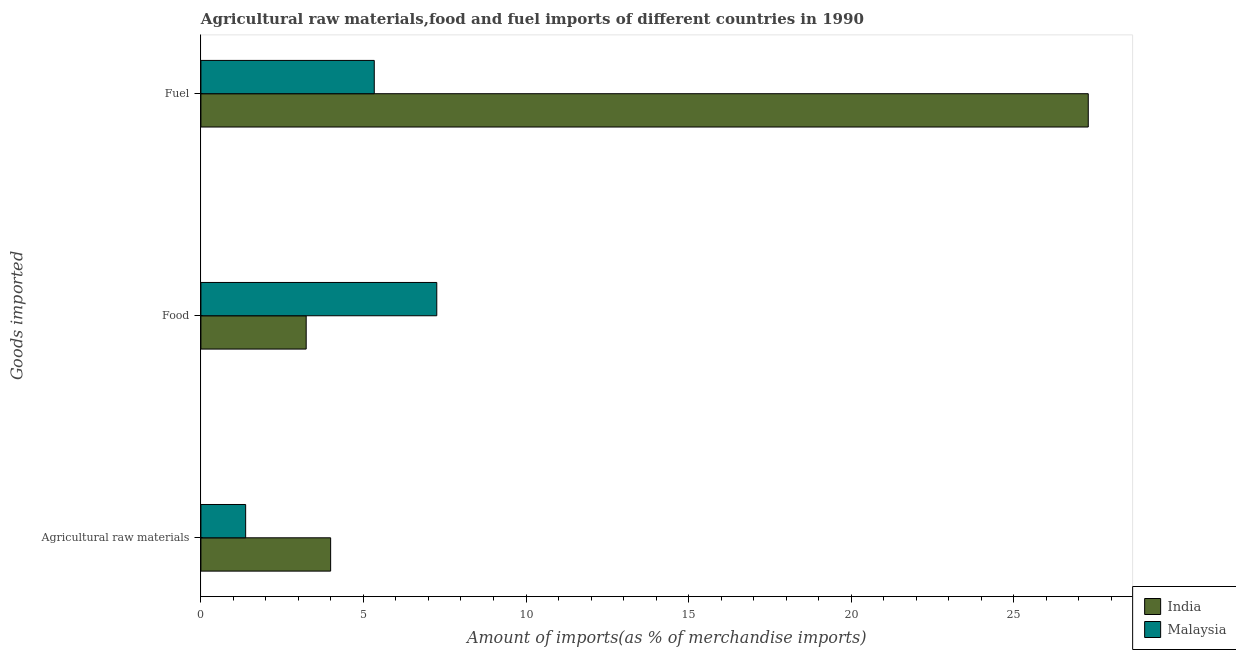How many different coloured bars are there?
Offer a terse response. 2. How many groups of bars are there?
Offer a terse response. 3. Are the number of bars on each tick of the Y-axis equal?
Ensure brevity in your answer.  Yes. How many bars are there on the 1st tick from the top?
Make the answer very short. 2. What is the label of the 2nd group of bars from the top?
Offer a very short reply. Food. What is the percentage of raw materials imports in Malaysia?
Make the answer very short. 1.38. Across all countries, what is the maximum percentage of raw materials imports?
Ensure brevity in your answer.  3.99. Across all countries, what is the minimum percentage of fuel imports?
Your response must be concise. 5.33. In which country was the percentage of raw materials imports maximum?
Give a very brief answer. India. In which country was the percentage of raw materials imports minimum?
Make the answer very short. Malaysia. What is the total percentage of fuel imports in the graph?
Your answer should be compact. 32.63. What is the difference between the percentage of food imports in India and that in Malaysia?
Offer a terse response. -4.02. What is the difference between the percentage of fuel imports in Malaysia and the percentage of raw materials imports in India?
Offer a very short reply. 1.34. What is the average percentage of food imports per country?
Your response must be concise. 5.25. What is the difference between the percentage of raw materials imports and percentage of food imports in India?
Offer a very short reply. 0.75. What is the ratio of the percentage of food imports in India to that in Malaysia?
Offer a terse response. 0.45. Is the difference between the percentage of fuel imports in Malaysia and India greater than the difference between the percentage of raw materials imports in Malaysia and India?
Provide a short and direct response. No. What is the difference between the highest and the second highest percentage of food imports?
Offer a very short reply. 4.02. What is the difference between the highest and the lowest percentage of fuel imports?
Your response must be concise. 21.96. Is the sum of the percentage of food imports in India and Malaysia greater than the maximum percentage of raw materials imports across all countries?
Make the answer very short. Yes. Is it the case that in every country, the sum of the percentage of raw materials imports and percentage of food imports is greater than the percentage of fuel imports?
Give a very brief answer. No. How many countries are there in the graph?
Keep it short and to the point. 2. Does the graph contain grids?
Your response must be concise. No. How many legend labels are there?
Offer a very short reply. 2. What is the title of the graph?
Ensure brevity in your answer.  Agricultural raw materials,food and fuel imports of different countries in 1990. Does "Montenegro" appear as one of the legend labels in the graph?
Provide a short and direct response. No. What is the label or title of the X-axis?
Your answer should be very brief. Amount of imports(as % of merchandise imports). What is the label or title of the Y-axis?
Make the answer very short. Goods imported. What is the Amount of imports(as % of merchandise imports) of India in Agricultural raw materials?
Keep it short and to the point. 3.99. What is the Amount of imports(as % of merchandise imports) in Malaysia in Agricultural raw materials?
Keep it short and to the point. 1.38. What is the Amount of imports(as % of merchandise imports) in India in Food?
Offer a very short reply. 3.24. What is the Amount of imports(as % of merchandise imports) in Malaysia in Food?
Offer a terse response. 7.26. What is the Amount of imports(as % of merchandise imports) in India in Fuel?
Your answer should be very brief. 27.3. What is the Amount of imports(as % of merchandise imports) of Malaysia in Fuel?
Give a very brief answer. 5.33. Across all Goods imported, what is the maximum Amount of imports(as % of merchandise imports) in India?
Ensure brevity in your answer.  27.3. Across all Goods imported, what is the maximum Amount of imports(as % of merchandise imports) in Malaysia?
Provide a succinct answer. 7.26. Across all Goods imported, what is the minimum Amount of imports(as % of merchandise imports) in India?
Make the answer very short. 3.24. Across all Goods imported, what is the minimum Amount of imports(as % of merchandise imports) in Malaysia?
Keep it short and to the point. 1.38. What is the total Amount of imports(as % of merchandise imports) of India in the graph?
Provide a short and direct response. 34.52. What is the total Amount of imports(as % of merchandise imports) in Malaysia in the graph?
Provide a short and direct response. 13.96. What is the difference between the Amount of imports(as % of merchandise imports) of India in Agricultural raw materials and that in Food?
Ensure brevity in your answer.  0.75. What is the difference between the Amount of imports(as % of merchandise imports) of Malaysia in Agricultural raw materials and that in Food?
Your response must be concise. -5.88. What is the difference between the Amount of imports(as % of merchandise imports) in India in Agricultural raw materials and that in Fuel?
Your answer should be very brief. -23.3. What is the difference between the Amount of imports(as % of merchandise imports) of Malaysia in Agricultural raw materials and that in Fuel?
Keep it short and to the point. -3.96. What is the difference between the Amount of imports(as % of merchandise imports) in India in Food and that in Fuel?
Offer a terse response. -24.06. What is the difference between the Amount of imports(as % of merchandise imports) in Malaysia in Food and that in Fuel?
Keep it short and to the point. 1.92. What is the difference between the Amount of imports(as % of merchandise imports) in India in Agricultural raw materials and the Amount of imports(as % of merchandise imports) in Malaysia in Food?
Offer a terse response. -3.26. What is the difference between the Amount of imports(as % of merchandise imports) of India in Agricultural raw materials and the Amount of imports(as % of merchandise imports) of Malaysia in Fuel?
Give a very brief answer. -1.34. What is the difference between the Amount of imports(as % of merchandise imports) of India in Food and the Amount of imports(as % of merchandise imports) of Malaysia in Fuel?
Make the answer very short. -2.09. What is the average Amount of imports(as % of merchandise imports) in India per Goods imported?
Provide a succinct answer. 11.51. What is the average Amount of imports(as % of merchandise imports) of Malaysia per Goods imported?
Your answer should be very brief. 4.65. What is the difference between the Amount of imports(as % of merchandise imports) in India and Amount of imports(as % of merchandise imports) in Malaysia in Agricultural raw materials?
Provide a succinct answer. 2.61. What is the difference between the Amount of imports(as % of merchandise imports) of India and Amount of imports(as % of merchandise imports) of Malaysia in Food?
Your response must be concise. -4.02. What is the difference between the Amount of imports(as % of merchandise imports) of India and Amount of imports(as % of merchandise imports) of Malaysia in Fuel?
Ensure brevity in your answer.  21.96. What is the ratio of the Amount of imports(as % of merchandise imports) of India in Agricultural raw materials to that in Food?
Keep it short and to the point. 1.23. What is the ratio of the Amount of imports(as % of merchandise imports) in Malaysia in Agricultural raw materials to that in Food?
Provide a succinct answer. 0.19. What is the ratio of the Amount of imports(as % of merchandise imports) of India in Agricultural raw materials to that in Fuel?
Your answer should be compact. 0.15. What is the ratio of the Amount of imports(as % of merchandise imports) of Malaysia in Agricultural raw materials to that in Fuel?
Give a very brief answer. 0.26. What is the ratio of the Amount of imports(as % of merchandise imports) of India in Food to that in Fuel?
Provide a short and direct response. 0.12. What is the ratio of the Amount of imports(as % of merchandise imports) in Malaysia in Food to that in Fuel?
Make the answer very short. 1.36. What is the difference between the highest and the second highest Amount of imports(as % of merchandise imports) in India?
Your answer should be very brief. 23.3. What is the difference between the highest and the second highest Amount of imports(as % of merchandise imports) of Malaysia?
Offer a terse response. 1.92. What is the difference between the highest and the lowest Amount of imports(as % of merchandise imports) in India?
Provide a short and direct response. 24.06. What is the difference between the highest and the lowest Amount of imports(as % of merchandise imports) in Malaysia?
Provide a succinct answer. 5.88. 